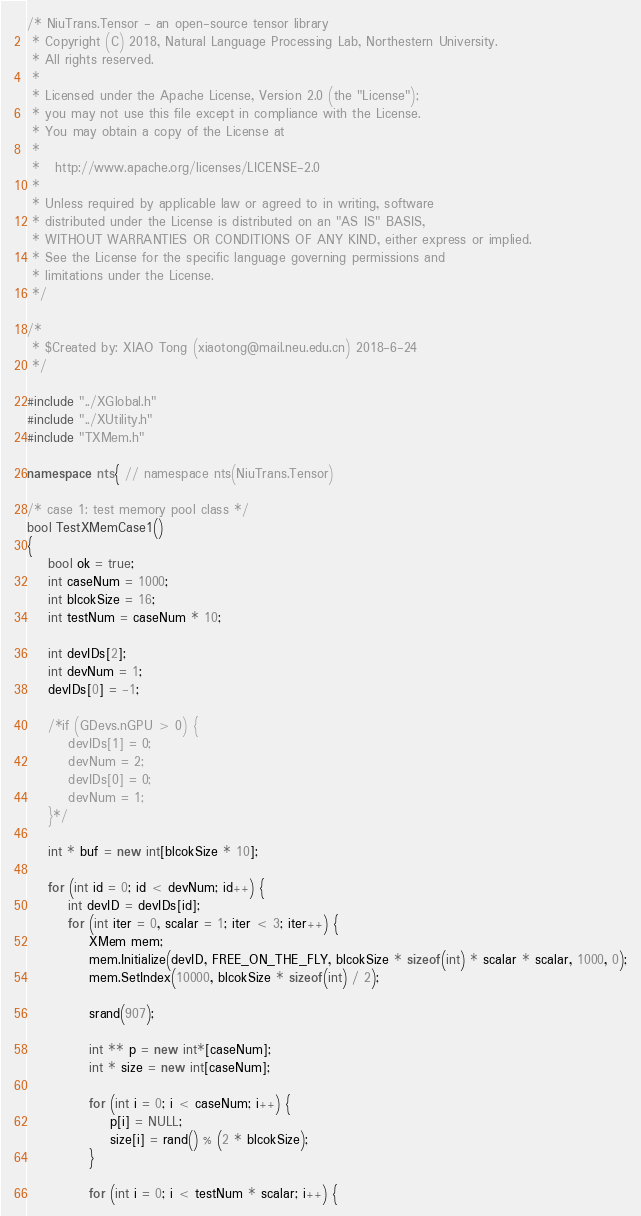<code> <loc_0><loc_0><loc_500><loc_500><_C++_>/* NiuTrans.Tensor - an open-source tensor library
 * Copyright (C) 2018, Natural Language Processing Lab, Northestern University. 
 * All rights reserved.
 *
 * Licensed under the Apache License, Version 2.0 (the "License");
 * you may not use this file except in compliance with the License.
 * You may obtain a copy of the License at
 *
 *   http://www.apache.org/licenses/LICENSE-2.0
 *
 * Unless required by applicable law or agreed to in writing, software
 * distributed under the License is distributed on an "AS IS" BASIS,
 * WITHOUT WARRANTIES OR CONDITIONS OF ANY KIND, either express or implied.
 * See the License for the specific language governing permissions and
 * limitations under the License.
 */

/*
 * $Created by: XIAO Tong (xiaotong@mail.neu.edu.cn) 2018-6-24
 */

#include "../XGlobal.h"
#include "../XUtility.h"
#include "TXMem.h"

namespace nts{ // namespace nts(NiuTrans.Tensor)

/* case 1: test memory pool class */
bool TestXMemCase1()
{
    bool ok = true;
    int caseNum = 1000;
    int blcokSize = 16;
    int testNum = caseNum * 10;

    int devIDs[2];
    int devNum = 1;
    devIDs[0] = -1;

    /*if (GDevs.nGPU > 0) {
        devIDs[1] = 0;
        devNum = 2;
        devIDs[0] = 0;
        devNum = 1;
    }*/

    int * buf = new int[blcokSize * 10];

    for (int id = 0; id < devNum; id++) {
        int devID = devIDs[id];
        for (int iter = 0, scalar = 1; iter < 3; iter++) {
            XMem mem;
            mem.Initialize(devID, FREE_ON_THE_FLY, blcokSize * sizeof(int) * scalar * scalar, 1000, 0);
            mem.SetIndex(10000, blcokSize * sizeof(int) / 2);

            srand(907);

            int ** p = new int*[caseNum];
            int * size = new int[caseNum];

            for (int i = 0; i < caseNum; i++) {
                p[i] = NULL;
                size[i] = rand() % (2 * blcokSize);
            }

            for (int i = 0; i < testNum * scalar; i++) {</code> 